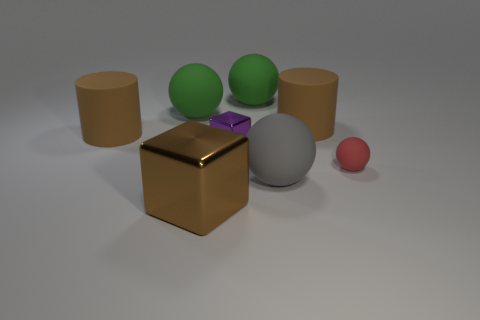What is the material of the tiny object that is left of the big brown object that is right of the small purple cube?
Keep it short and to the point. Metal. How many big brown matte objects are to the right of the gray object?
Your answer should be compact. 1. Are there more small purple metallic objects that are to the right of the large brown block than large green matte cylinders?
Give a very brief answer. Yes. What is the shape of the tiny thing that is the same material as the large gray object?
Provide a short and direct response. Sphere. The ball that is to the right of the large brown cylinder to the right of the purple shiny object is what color?
Ensure brevity in your answer.  Red. Do the big metal thing and the small metallic thing have the same shape?
Offer a very short reply. Yes. There is a small red object that is the same shape as the large gray object; what is it made of?
Keep it short and to the point. Rubber. There is a rubber ball on the right side of the brown rubber thing to the right of the large brown shiny cube; are there any tiny metal objects that are behind it?
Offer a terse response. Yes. Is the shape of the red object the same as the green thing that is on the left side of the big brown cube?
Your answer should be very brief. Yes. Are there any other things that are the same color as the tiny sphere?
Make the answer very short. No. 